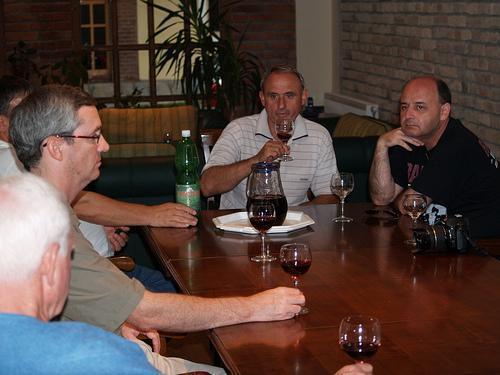How many people are in the picture?
Give a very brief answer. 5. How many people are drinking?
Give a very brief answer. 5. How many couches can be seen?
Give a very brief answer. 2. How many people are visible?
Give a very brief answer. 5. How many levels does the bus have?
Give a very brief answer. 0. 